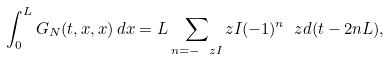<formula> <loc_0><loc_0><loc_500><loc_500>\int _ { 0 } ^ { L } G _ { N } ( t , x , x ) \, d x = L \sum _ { n = - \ z I } ^ { \ } z I ( - 1 ) ^ { n } \ z d ( t - 2 n L ) ,</formula> 